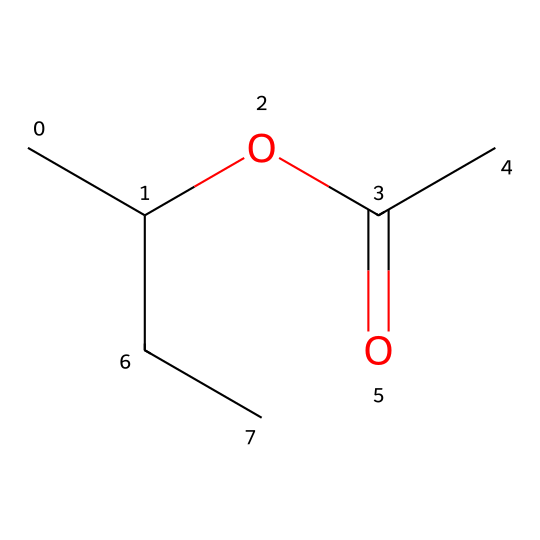What is the main functional group in this chemical? The chemical structure shows a carbonyl group (C=O) adjacent to a hydroxyl group (-OH), which is characteristic of esters. Thus, the main functional group is an ester.
Answer: ester How many carbon atoms are present in the molecule? By examining the SMILES representation, there are four carbon atoms in total. The backbone consists of three in the chain with one attached through the carbonyl.
Answer: four What is the molecular formula derived from the SMILES? Analyzing the chemical structure reveals the number of different atoms: 4 carbons, 8 hydrogens, and 2 oxygens. Therefore, the molecular formula is C4H8O2.
Answer: C4H8O2 What type of liquid is this chemical likely to be? Considering the ester functional group and its properties, it is likely to be a non-polar or slightly polar liquid. Esters are commonly found in adhesive formulations, which makes it suitable for use in set design.
Answer: non-polar liquid What type of bonding is primarily responsible for adhesion in this chemical? The presence of the ester group allows for hydrogen bonding and van der Waals interactions, which are significant in adhesion properties for compounds like this.
Answer: hydrogen bonding What might be a common use for this chemical in set design? Given its properties as an adhesive and its compatibility with various materials, it is commonly used for bonding decorative elements or lightweight pieces in set design.
Answer: adhesive What effect does the presence of the carboxylic acid group have on the chemical's solubility? The carboxylic acid group enhances the solubility in polar solvents due to its ability to form hydrogen bonds, making it more effective for bonding in moist environments often encountered in theater settings.
Answer: enhances solubility 